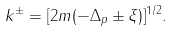<formula> <loc_0><loc_0><loc_500><loc_500>k ^ { \pm } = [ 2 m ( - \Delta _ { p } \pm \xi ) ] ^ { 1 / 2 } .</formula> 